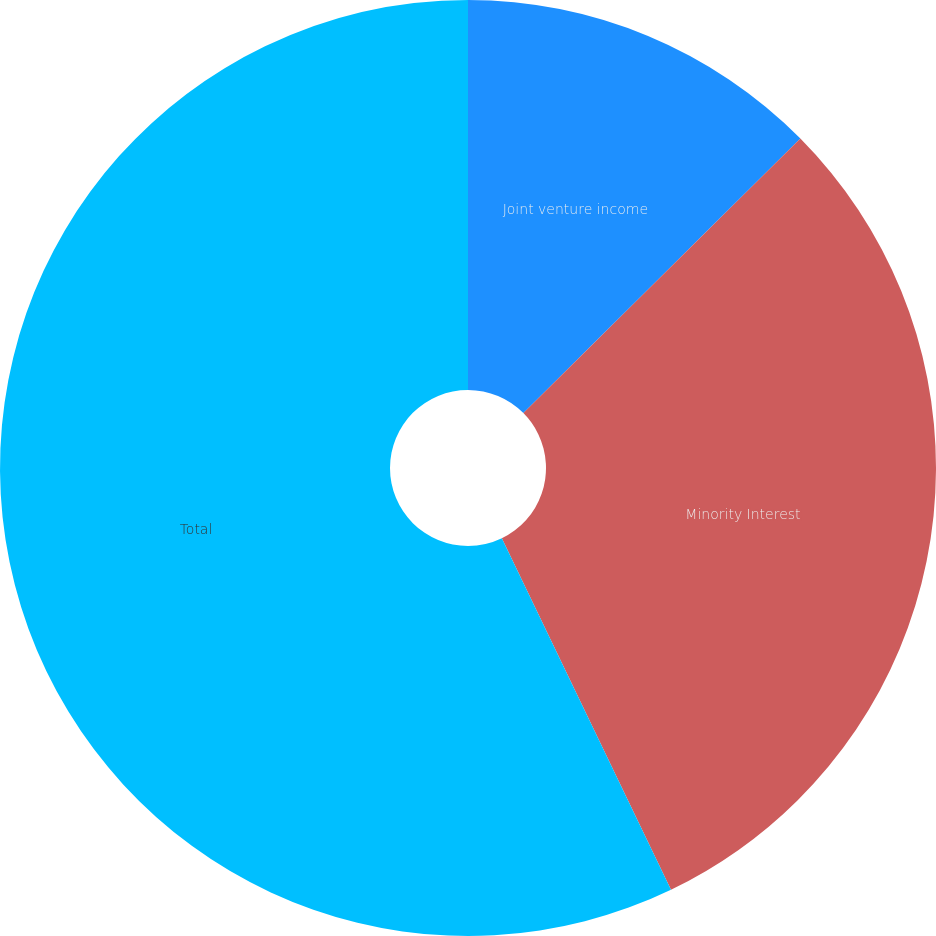<chart> <loc_0><loc_0><loc_500><loc_500><pie_chart><fcel>Joint venture income<fcel>Minority Interest<fcel>Total<nl><fcel>12.57%<fcel>30.29%<fcel>57.14%<nl></chart> 